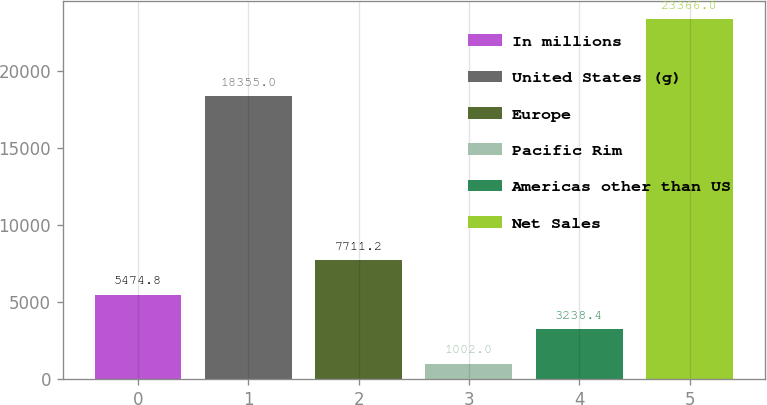<chart> <loc_0><loc_0><loc_500><loc_500><bar_chart><fcel>In millions<fcel>United States (g)<fcel>Europe<fcel>Pacific Rim<fcel>Americas other than US<fcel>Net Sales<nl><fcel>5474.8<fcel>18355<fcel>7711.2<fcel>1002<fcel>3238.4<fcel>23366<nl></chart> 